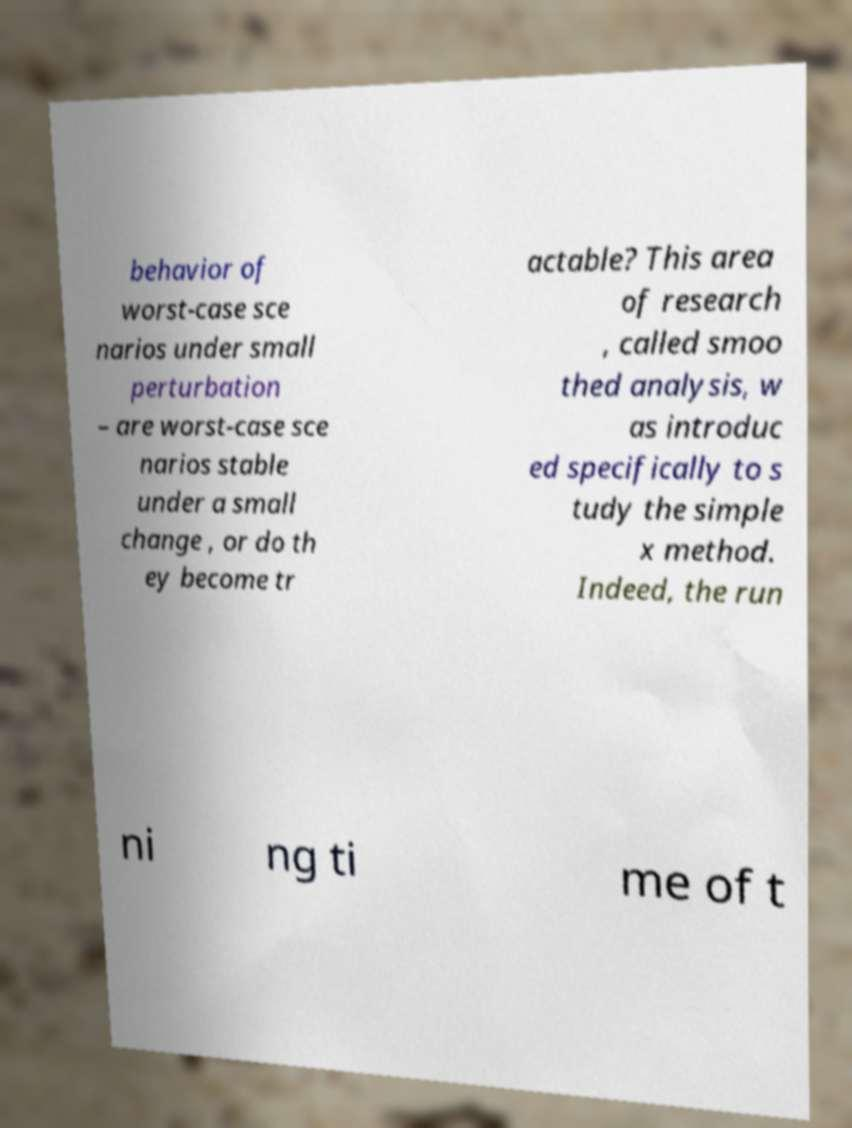Please identify and transcribe the text found in this image. behavior of worst-case sce narios under small perturbation – are worst-case sce narios stable under a small change , or do th ey become tr actable? This area of research , called smoo thed analysis, w as introduc ed specifically to s tudy the simple x method. Indeed, the run ni ng ti me of t 